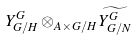Convert formula to latex. <formula><loc_0><loc_0><loc_500><loc_500>Y _ { G / H } ^ { G } \otimes _ { A \times G / H } \widetilde { Y _ { G / N } ^ { G } }</formula> 